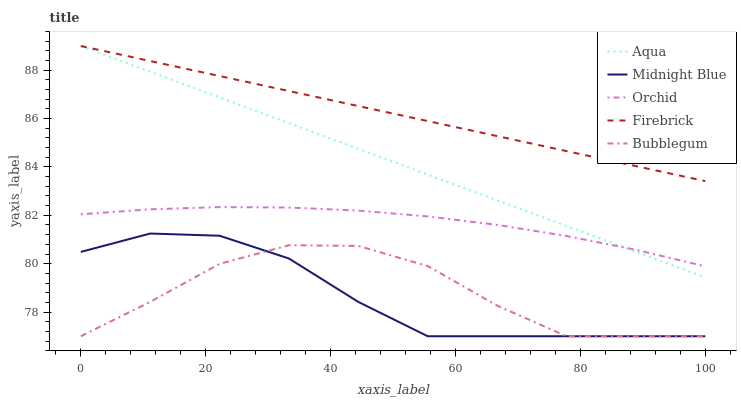Does Midnight Blue have the minimum area under the curve?
Answer yes or no. Yes. Does Firebrick have the maximum area under the curve?
Answer yes or no. Yes. Does Aqua have the minimum area under the curve?
Answer yes or no. No. Does Aqua have the maximum area under the curve?
Answer yes or no. No. Is Firebrick the smoothest?
Answer yes or no. Yes. Is Bubblegum the roughest?
Answer yes or no. Yes. Is Aqua the smoothest?
Answer yes or no. No. Is Aqua the roughest?
Answer yes or no. No. Does Aqua have the lowest value?
Answer yes or no. No. Does Aqua have the highest value?
Answer yes or no. Yes. Does Midnight Blue have the highest value?
Answer yes or no. No. Is Bubblegum less than Orchid?
Answer yes or no. Yes. Is Orchid greater than Midnight Blue?
Answer yes or no. Yes. Does Orchid intersect Aqua?
Answer yes or no. Yes. Is Orchid less than Aqua?
Answer yes or no. No. Is Orchid greater than Aqua?
Answer yes or no. No. Does Bubblegum intersect Orchid?
Answer yes or no. No. 